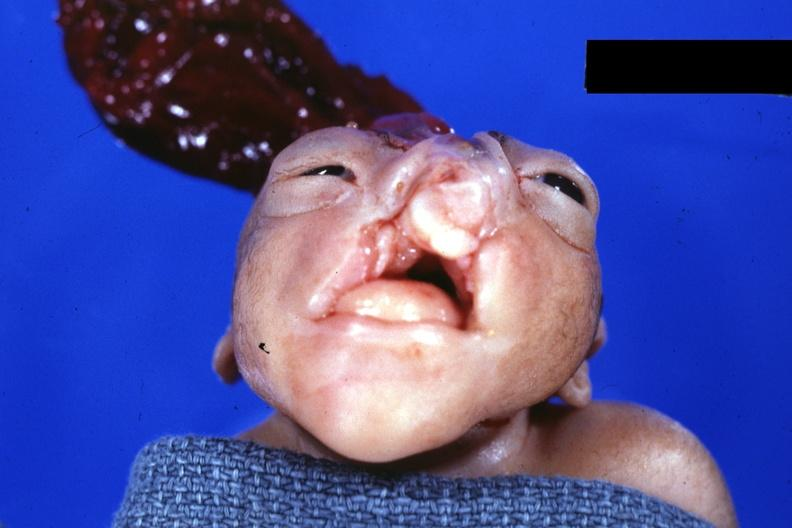s endometritis postpartum present?
Answer the question using a single word or phrase. No 